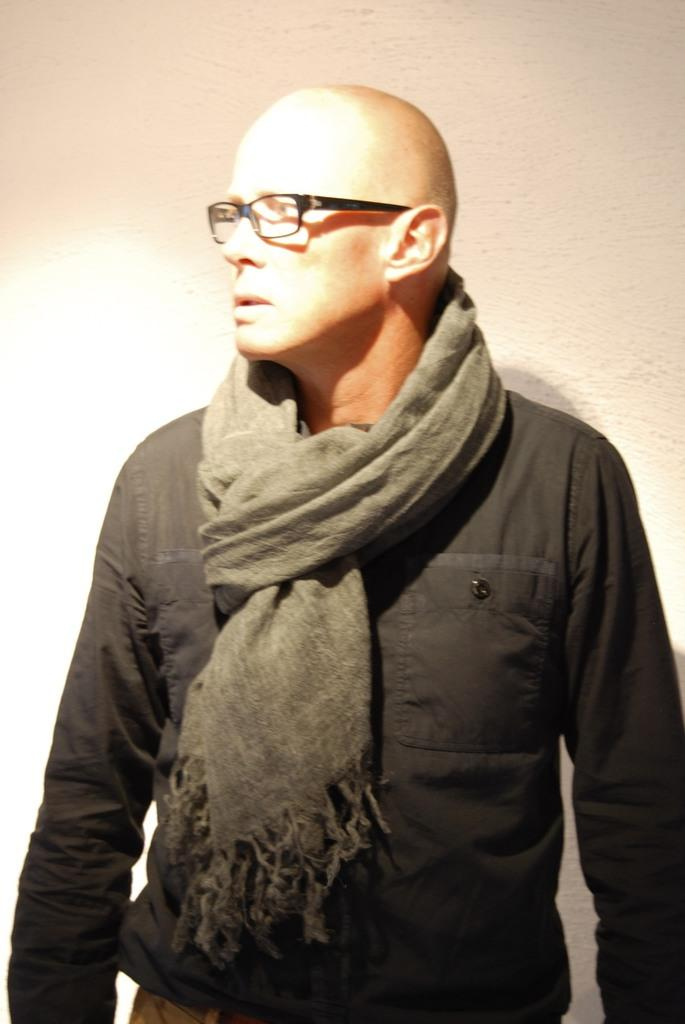What is the main subject of the image? There is a person standing in the center of the image. Can you describe the person's appearance? The person is wearing spectacles. What can be seen in the background of the image? There is a wall in the background of the image. What is the price of the land visible in the image? There is no land visible in the image; it only features a person standing in front of a wall. 